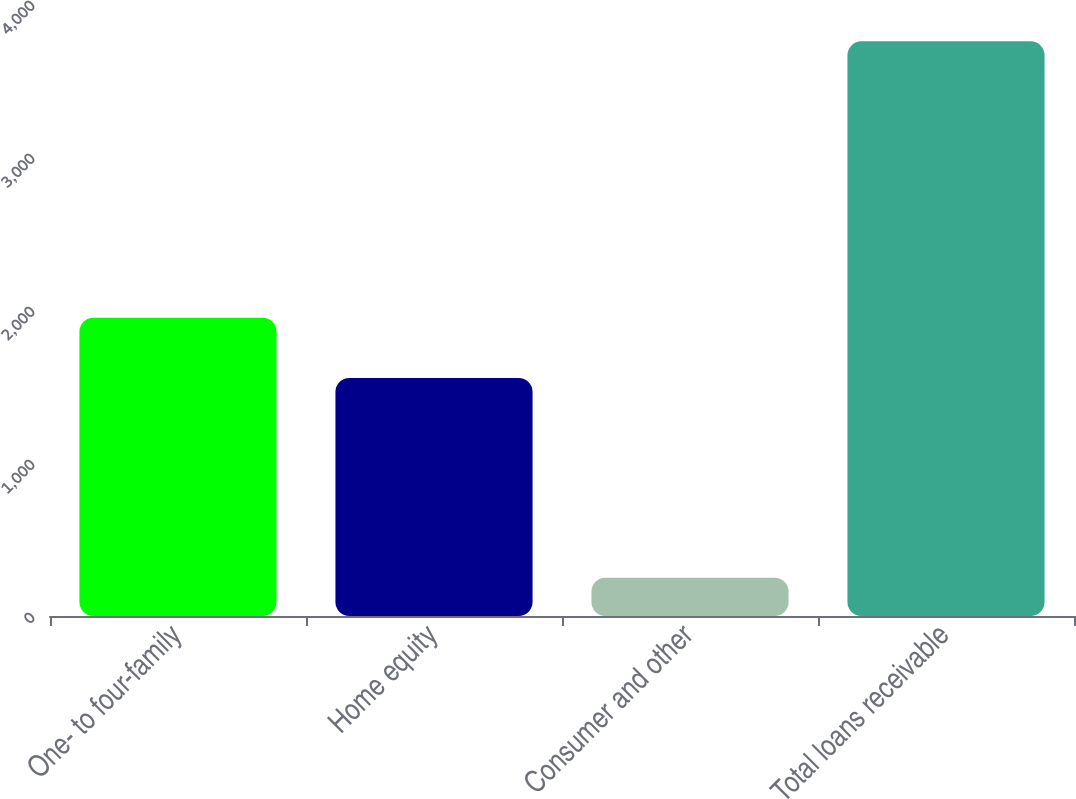<chart> <loc_0><loc_0><loc_500><loc_500><bar_chart><fcel>One- to four-family<fcel>Home equity<fcel>Consumer and other<fcel>Total loans receivable<nl><fcel>1950<fcel>1556<fcel>250<fcel>3756<nl></chart> 